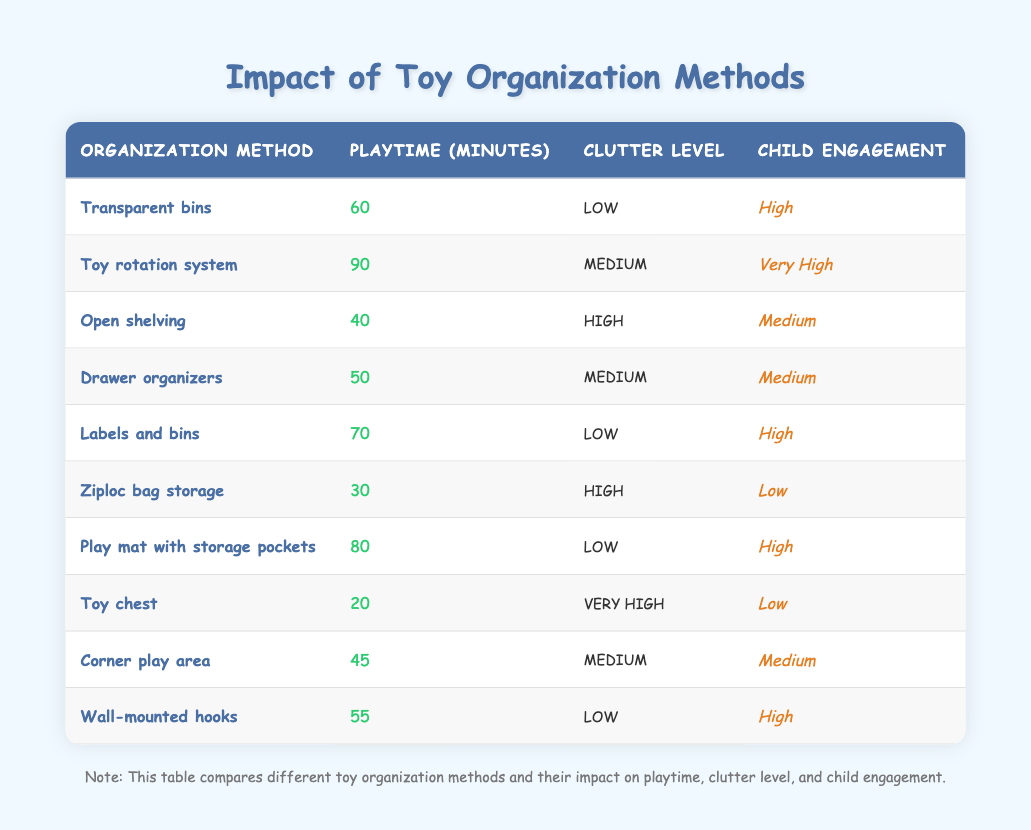What is the playtime in minutes for the "Toy rotation system"? The table shows that the "Toy rotation system" has a playtime of 90 minutes.
Answer: 90 Which toy organization method has a low clutter level but very high child engagement? The method "Toy rotation system" has a medium clutter level but the methods "Transparent bins", "Labels and bins", "Play mat with storage pockets", and "Wall-mounted hooks" all have a low clutter level but only "Toy rotation system" has very high child engagement.
Answer: No What is the total playtime for all methods with low clutter levels? The playtime for low clutter methods is calculated by adding the minutes: 60 (Transparent bins) + 70 (Labels and bins) + 80 (Play mat with storage pockets) + 55 (Wall-mounted hooks) = 265.
Answer: 265 How many organization methods have high engagement and low clutter? The table lists four methods with high engagement and low clutter: "Transparent bins", "Labels and bins", "Play mat with storage pockets", and "Wall-mounted hooks".
Answer: 4 Is the playtime longer for methods with high clutter than those with low clutter? For high clutter methods (Open shelving, Ziploc bag storage, Toy chest), the playtimes are 40, 30, and 20 respectively, totaling 90 minutes. For low clutter methods, the total is 265 minutes. Thus, playtime is shorter for high clutter methods.
Answer: No What is the average playtime for toy organization methods with medium clutter levels? The methods with medium clutter are "Toy rotation system" (90 min), "Drawer organizers" (50 min), and "Corner play area" (45 min). The total is 185 minutes and with 3 methods, the average is 185/3 = 61.67, which is approximately 62 minutes.
Answer: 62 Which method has the shortest playtime and how much is it? The method with the shortest playtime is "Toy chest" with a playtime of 20 minutes, as clearly indicated in the table.
Answer: 20 What is the relationship between clutter level and child engagement for the "Ziploc bag storage" method? The "Ziploc bag storage" method has a high clutter level and low child engagement, indicating that higher clutter correlates with lower engagement in this case.
Answer: High clutter, low engagement 